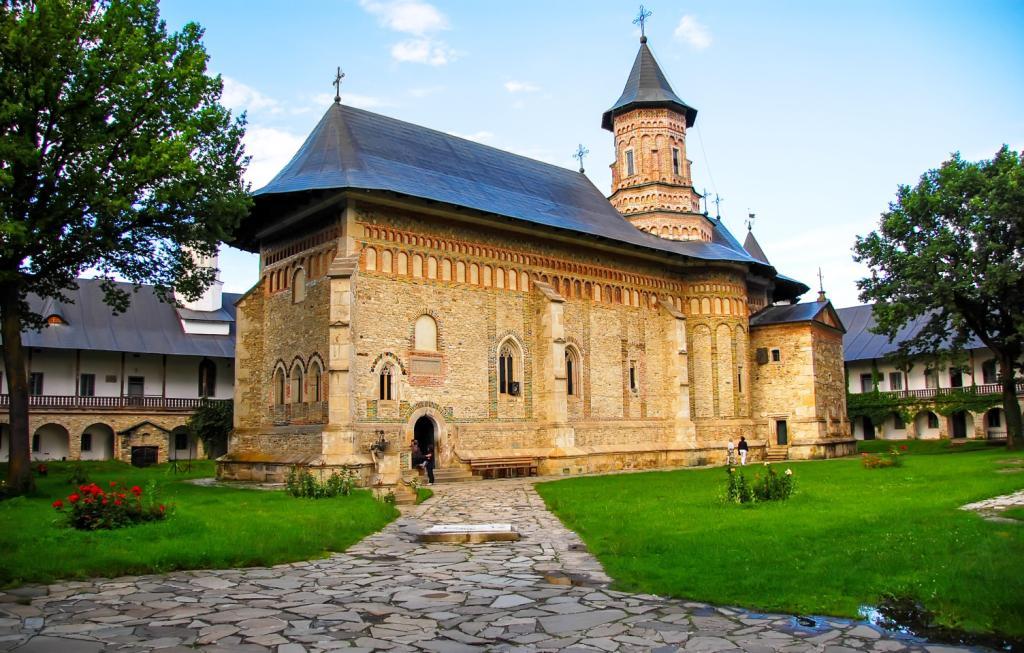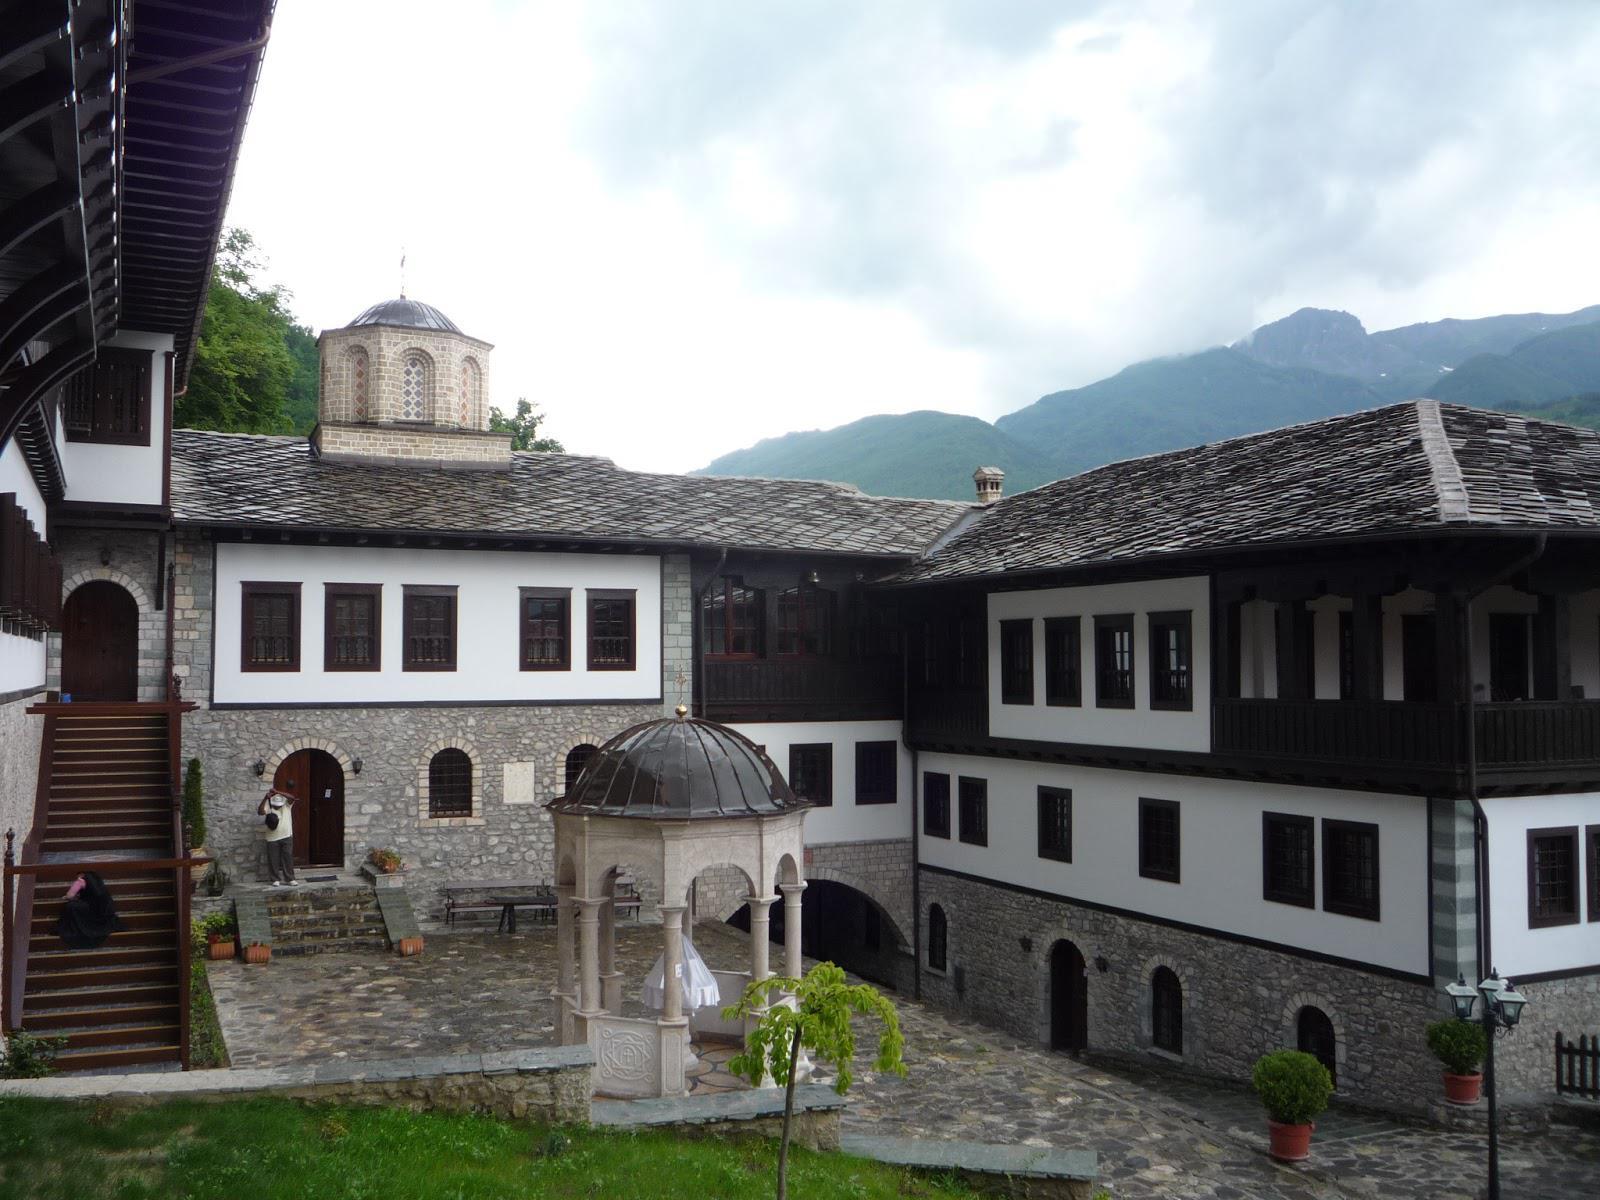The first image is the image on the left, the second image is the image on the right. Evaluate the accuracy of this statement regarding the images: "At least one image shows a sprawling building that includes a dark blue-gray cone roof on a cylindrical tower.". Is it true? Answer yes or no. Yes. 